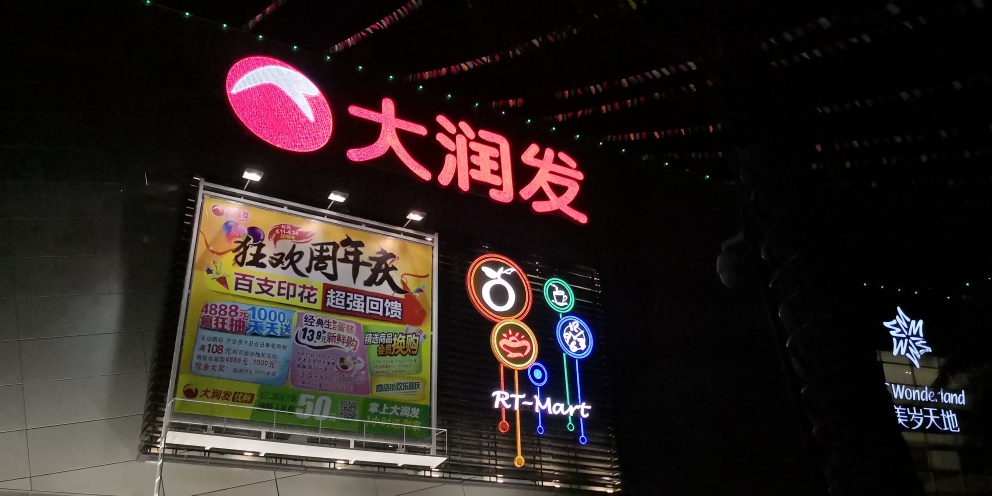What does the surrounding environment suggest about the location these signs are in? The surrounding environment, with its dark sky and absence of visible natural light, might indicate an urban setting where large illuminated signs are necessary for visibility at night. The presence of several large advertisements together suggests this may be a commercial area, focusing on retail and leisure, aimed at drawing in consumers during the evening hours. 